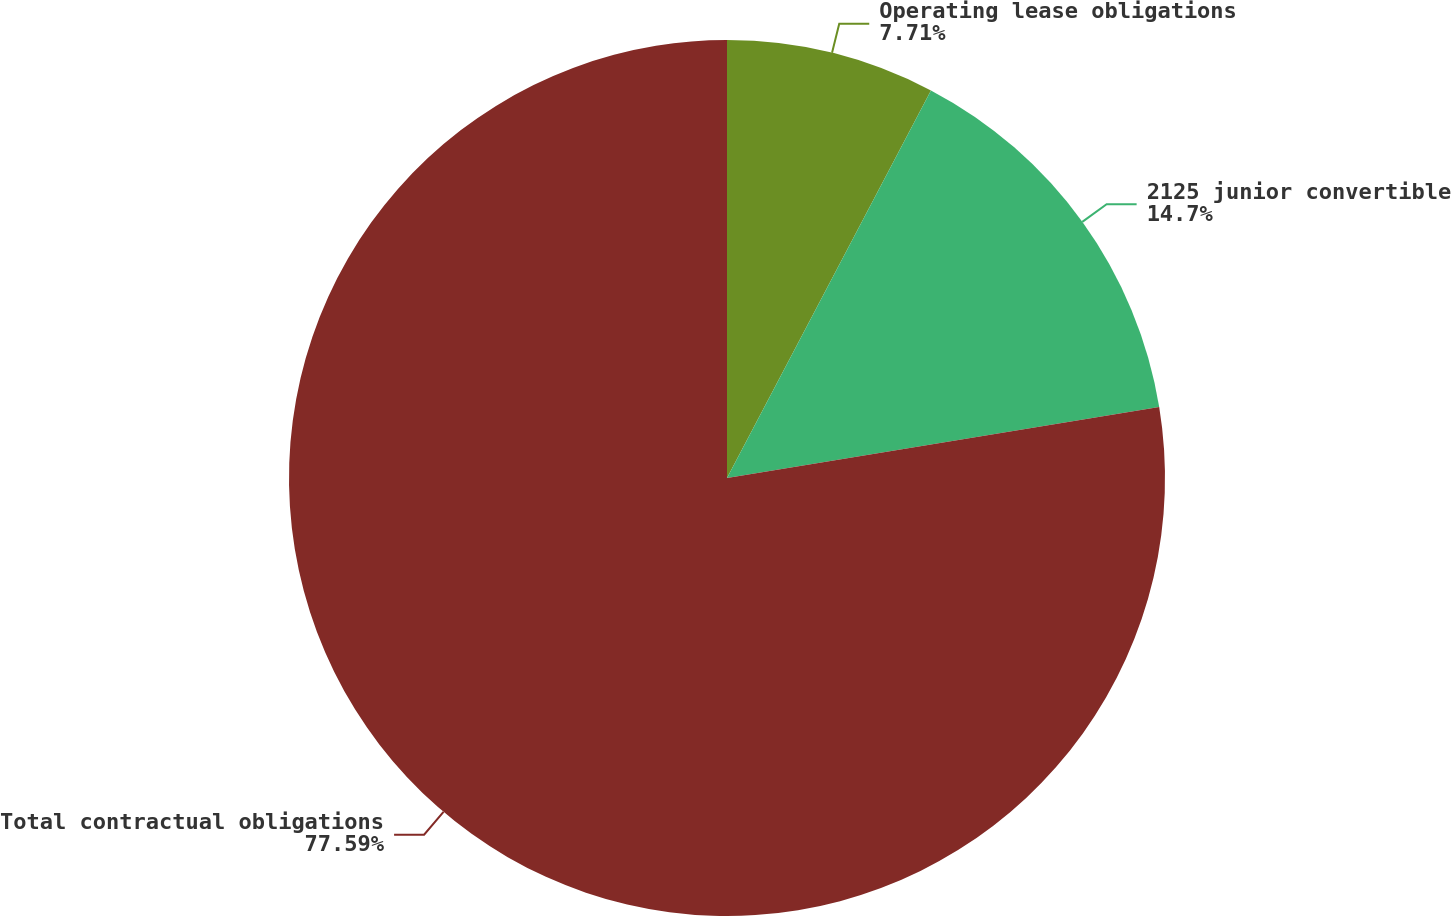<chart> <loc_0><loc_0><loc_500><loc_500><pie_chart><fcel>Operating lease obligations<fcel>2125 junior convertible<fcel>Total contractual obligations<nl><fcel>7.71%<fcel>14.7%<fcel>77.6%<nl></chart> 